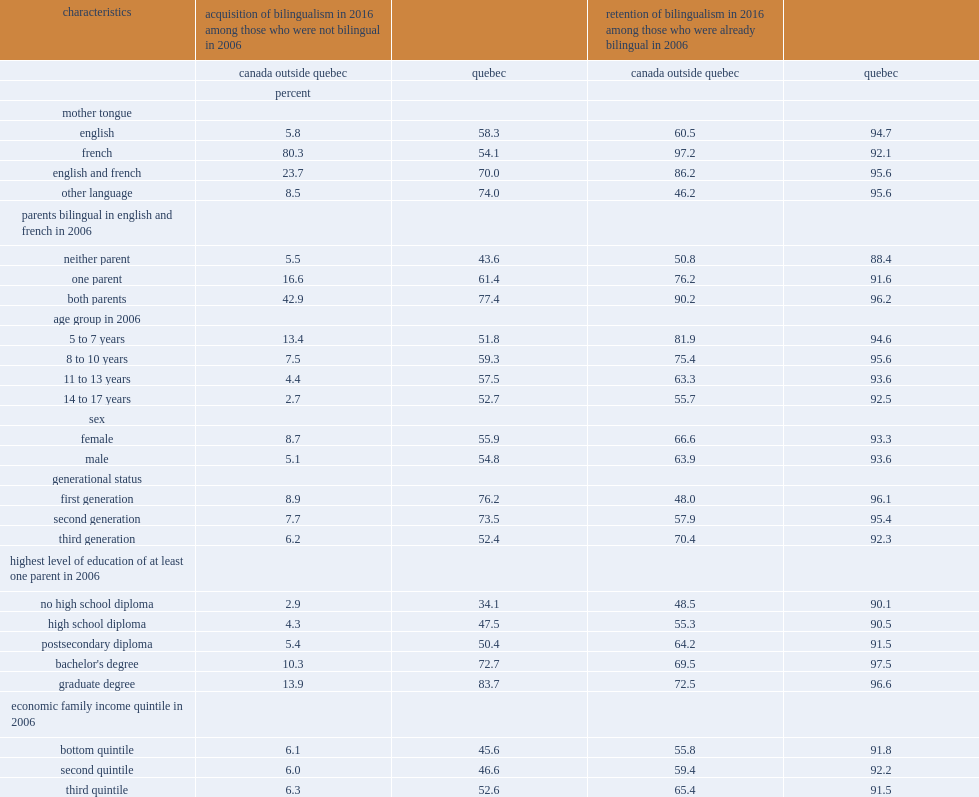What was the english-french bilingualism acquisition rate in 2016 for youth in quebec whose parents had a bachelor's degree? 72.7. What wast the english-french bilingualism acquisition rate in 2016 for youth in quebec whose parents had a high school diploma? 47.5. What was the retention rates for quebec children and youth who were bilingual in english and french in 2006 for all age groups? 95.6. In canada outside quebec, which bilingual youth group in 2006 had a lower retention rate in children , aged 14 to 17 or aged 5 to 7? 14 to 17 years. 